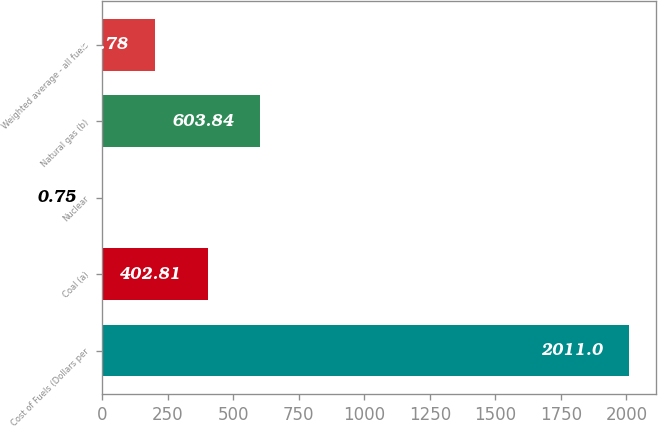Convert chart to OTSL. <chart><loc_0><loc_0><loc_500><loc_500><bar_chart><fcel>Cost of Fuels (Dollars per<fcel>Coal (a)<fcel>Nuclear<fcel>Natural gas (b)<fcel>Weighted average - all fuels<nl><fcel>2011<fcel>402.81<fcel>0.75<fcel>603.84<fcel>201.78<nl></chart> 